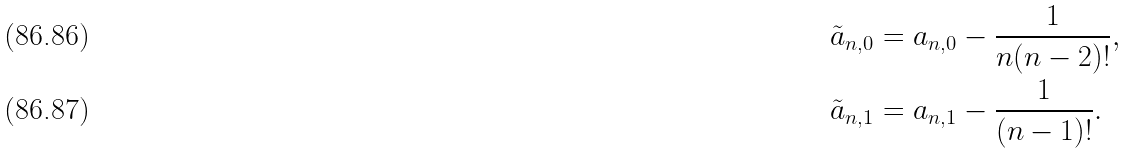<formula> <loc_0><loc_0><loc_500><loc_500>\tilde { a } _ { n , 0 } & = a _ { n , 0 } - \frac { 1 } { n ( n - 2 ) ! } , \\ \tilde { a } _ { n , 1 } & = a _ { n , 1 } - \frac { 1 } { ( n - 1 ) ! } .</formula> 